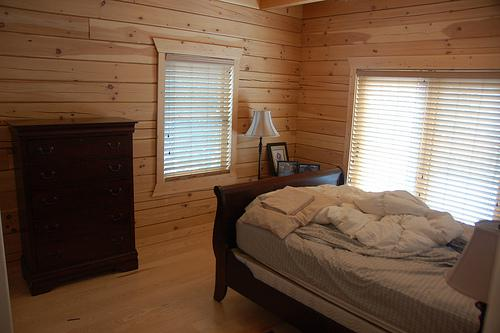Question: where was this picture taken?
Choices:
A. Dining room.
B. Kitchen.
C. Bathroom.
D. A bedroom.
Answer with the letter. Answer: D Question: how many people are pictured here?
Choices:
A. Two.
B. Zero.
C. Three.
D. Four.
Answer with the letter. Answer: B Question: what are the walls made of?
Choices:
A. Wood.
B. Concrete.
C. Stone.
D. Brick.
Answer with the letter. Answer: A Question: how many lamps are in the photo?
Choices:
A. Four.
B. Three.
C. Ten.
D. Two.
Answer with the letter. Answer: D 